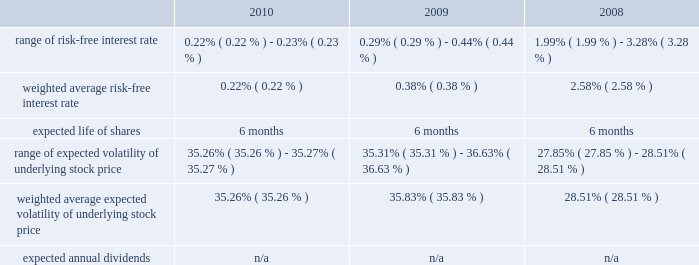American tower corporation and subsidiaries notes to consolidated financial statements as of december 31 , 2010 , total unrecognized compensation expense related to unvested restricted stock units granted under the 2007 plan was $ 57.5 million and is expected to be recognized over a weighted average period of approximately two years .
Employee stock purchase plan 2014the company maintains an employee stock purchase plan ( 201cespp 201d ) for all eligible employees .
Under the espp , shares of the company 2019s common stock may be purchased during bi-annual offering periods at 85% ( 85 % ) of the lower of the fair market value on the first or the last day of each offering period .
Employees may purchase shares having a value not exceeding 15% ( 15 % ) of their gross compensation during an offering period and may not purchase more than $ 25000 worth of stock in a calendar year ( based on market values at the beginning of each offering period ) .
The offering periods run from june 1 through november 30 and from december 1 through may 31 of each year .
During the 2010 , 2009 and 2008 offering periods employees purchased 75354 , 77509 and 55764 shares , respectively , at weighted average prices per share of $ 34.16 , $ 23.91 and $ 30.08 , respectively .
The fair value of the espp offerings is estimated on the offering period commencement date using a black-scholes pricing model with the expense recognized over the expected life , which is the six month offering period over which employees accumulate payroll deductions to purchase the company 2019s common stock .
The weighted average fair value for the espp shares purchased during 2010 , 2009 and 2008 was $ 9.43 , $ 6.65 and $ 7.89 , respectively .
At december 31 , 2010 , 8.7 million shares remain reserved for future issuance under the plan .
Key assumptions used to apply this pricing model for the years ended december 31 , are as follows: .
13 .
Stockholders 2019 equity warrants 2014in august 2005 , the company completed its merger with spectrasite , inc .
And assumed outstanding warrants to purchase shares of spectrasite , inc .
Common stock .
As of the merger completion date , each warrant was exercisable for two shares of spectrasite , inc .
Common stock at an exercise price of $ 32 per warrant .
Upon completion of the merger , each warrant to purchase shares of spectrasite , inc .
Common stock automatically converted into a warrant to purchase shares of the company 2019s common stock , such that upon exercise of each warrant , the holder has a right to receive 3.575 shares of the company 2019s common stock in lieu of each share of spectrasite , inc .
Common stock that would have been receivable under each assumed warrant prior to the merger .
Upon completion of the company 2019s merger with spectrasite , inc. , these warrants were exercisable for approximately 6.8 million shares of common stock .
Of these warrants , warrants to purchase approximately none and 1.7 million shares of common stock remained outstanding as of december 31 , 2010 and 2009 , respectively .
These warrants expired on february 10 , 2010 .
Stock repurchase program 2014during the year ended december 31 , 2010 , the company repurchased an aggregate of approximately 9.3 million shares of its common stock for an aggregate of $ 420.8 million , including commissions and fees , of which $ 418.6 million was paid in cash prior to december 31 , 2010 and $ 2.2 million was included in accounts payable and accrued expenses in the accompanying consolidated balance sheet as of december 31 , 2010 , pursuant to its publicly announced stock repurchase program , as described below. .
What was the percentage change in the weighted average fair value for the espp shares purchased from 2009 to 2010? 
Computations: ((9.43 - 6.65) / 6.65)
Answer: 0.41805. 